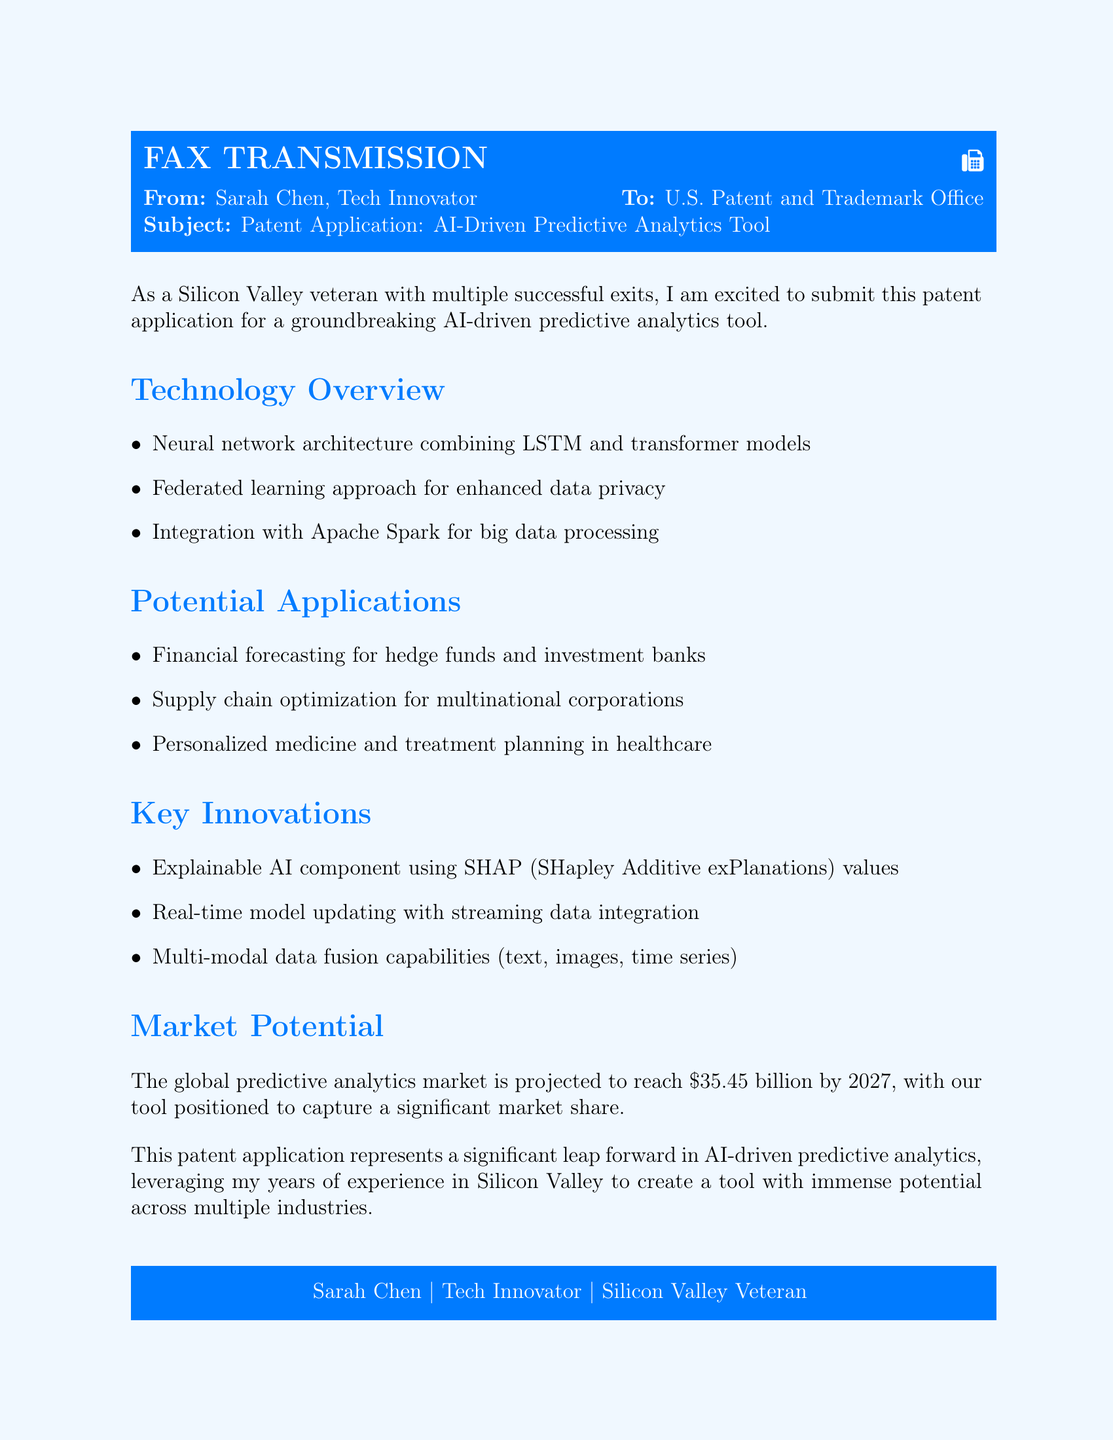What is the name of the tool described in the patent application? The document mentions the "AI-driven predictive analytics tool" as the subject of the patent application.
Answer: AI-driven predictive analytics tool What neural network architectures are combined in the technology? The document lists "LSTM and transformer models" as the neural network architectures used in the tool.
Answer: LSTM and transformer models What approach is used for enhancing data privacy? The application describes utilizing a "federated learning approach" for improved data privacy.
Answer: Federated learning What is one key innovation included in the tool? The document highlights "Explainable AI component using SHAP values" as a key innovation.
Answer: Explainable AI component using SHAP values What is the projected value of the global predictive analytics market by 2027? The document states that the market is projected to reach "$35.45 billion by 2027."
Answer: $35.45 billion Which industry could benefit from personalized medicine mentioned in the applications? "Healthcare" is identified as one of the industries where personalized medicine applications could be used.
Answer: Healthcare What technology is integrated for big data processing? The document specifies "Apache Spark" as the technology integrated for big data processing.
Answer: Apache Spark What does the tool enable with "real-time model updating"? The tool enables "streaming data integration" with its real-time model updating capability.
Answer: Streaming data integration What company title does the fax originate from? The document identifies the sender as "Tech Innovator."
Answer: Tech Innovator 